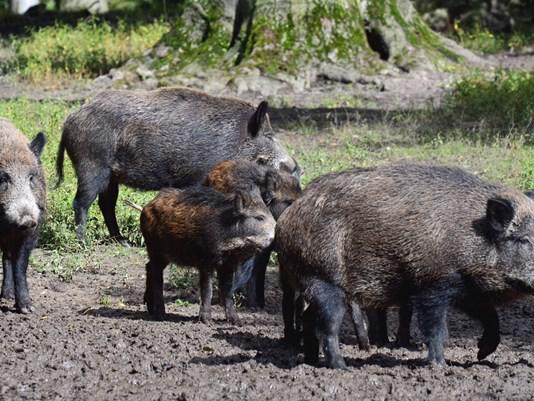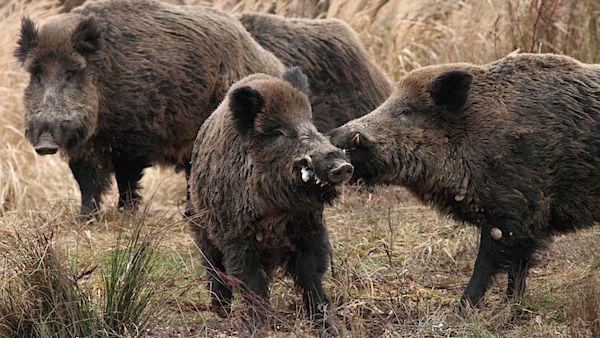The first image is the image on the left, the second image is the image on the right. Evaluate the accuracy of this statement regarding the images: "There are no more than 4 animals in the image on the right.". Is it true? Answer yes or no. Yes. 